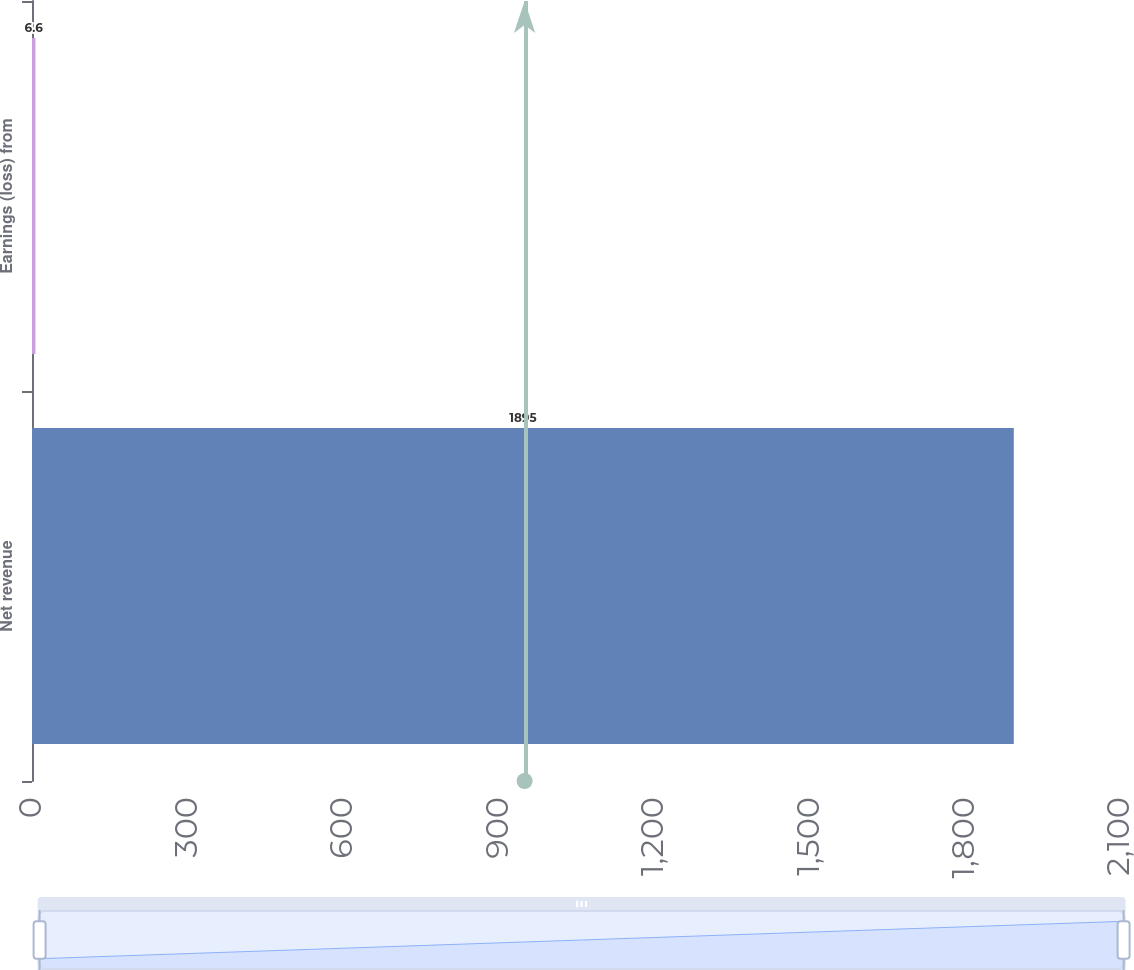Convert chart to OTSL. <chart><loc_0><loc_0><loc_500><loc_500><bar_chart><fcel>Net revenue<fcel>Earnings (loss) from<nl><fcel>1895<fcel>6.6<nl></chart> 